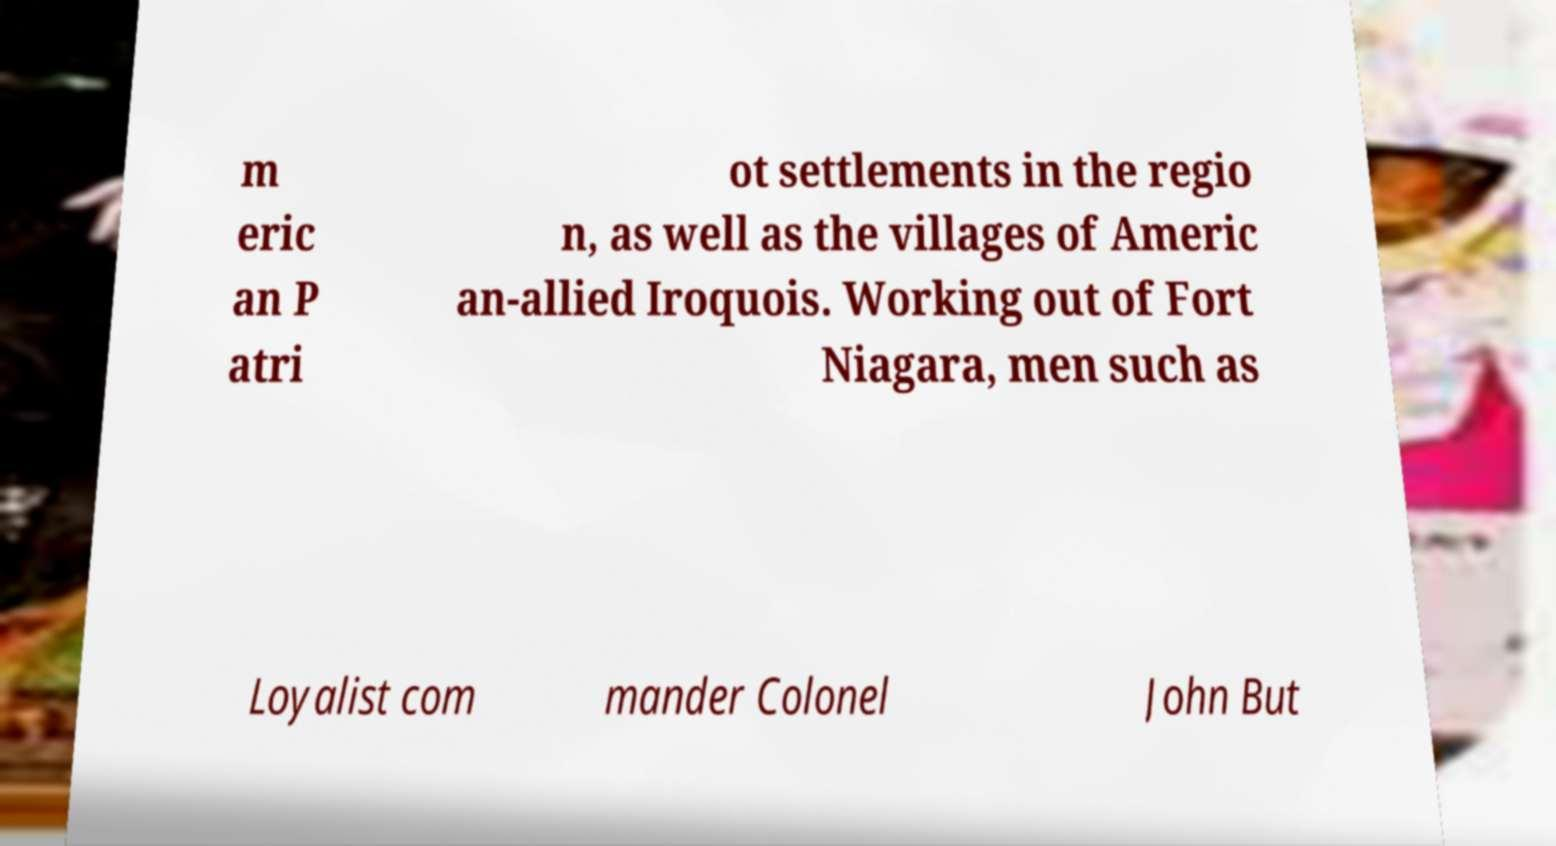Can you accurately transcribe the text from the provided image for me? m eric an P atri ot settlements in the regio n, as well as the villages of Americ an-allied Iroquois. Working out of Fort Niagara, men such as Loyalist com mander Colonel John But 